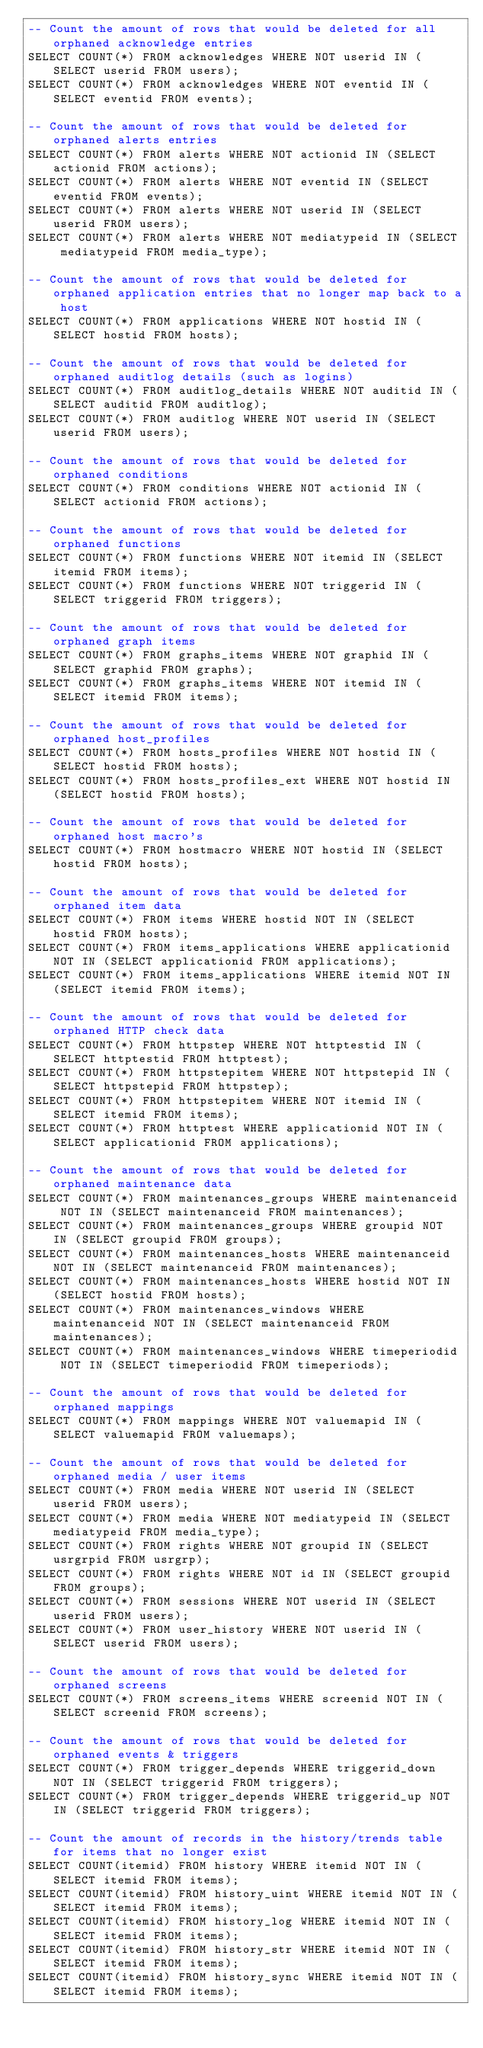<code> <loc_0><loc_0><loc_500><loc_500><_SQL_>-- Count the amount of rows that would be deleted for all orphaned acknowledge entries
SELECT COUNT(*) FROM acknowledges WHERE NOT userid IN (SELECT userid FROM users);
SELECT COUNT(*) FROM acknowledges WHERE NOT eventid IN (SELECT eventid FROM events);

-- Count the amount of rows that would be deleted for orphaned alerts entries
SELECT COUNT(*) FROM alerts WHERE NOT actionid IN (SELECT actionid FROM actions);
SELECT COUNT(*) FROM alerts WHERE NOT eventid IN (SELECT eventid FROM events);
SELECT COUNT(*) FROM alerts WHERE NOT userid IN (SELECT userid FROM users);
SELECT COUNT(*) FROM alerts WHERE NOT mediatypeid IN (SELECT mediatypeid FROM media_type);

-- Count the amount of rows that would be deleted for orphaned application entries that no longer map back to a host
SELECT COUNT(*) FROM applications WHERE NOT hostid IN (SELECT hostid FROM hosts);

-- Count the amount of rows that would be deleted for orphaned auditlog details (such as logins)
SELECT COUNT(*) FROM auditlog_details WHERE NOT auditid IN (SELECT auditid FROM auditlog);
SELECT COUNT(*) FROM auditlog WHERE NOT userid IN (SELECT userid FROM users);

-- Count the amount of rows that would be deleted for orphaned conditions
SELECT COUNT(*) FROM conditions WHERE NOT actionid IN (SELECT actionid FROM actions);

-- Count the amount of rows that would be deleted for orphaned functions
SELECT COUNT(*) FROM functions WHERE NOT itemid IN (SELECT itemid FROM items);
SELECT COUNT(*) FROM functions WHERE NOT triggerid IN (SELECT triggerid FROM triggers);

-- Count the amount of rows that would be deleted for orphaned graph items
SELECT COUNT(*) FROM graphs_items WHERE NOT graphid IN (SELECT graphid FROM graphs);
SELECT COUNT(*) FROM graphs_items WHERE NOT itemid IN (SELECT itemid FROM items);

-- Count the amount of rows that would be deleted for orphaned host_profiles
SELECT COUNT(*) FROM hosts_profiles WHERE NOT hostid IN (SELECT hostid FROM hosts);
SELECT COUNT(*) FROM hosts_profiles_ext WHERE NOT hostid IN (SELECT hostid FROM hosts);

-- Count the amount of rows that would be deleted for orphaned host macro's
SELECT COUNT(*) FROM hostmacro WHERE NOT hostid IN (SELECT hostid FROM hosts);

-- Count the amount of rows that would be deleted for orphaned item data
SELECT COUNT(*) FROM items WHERE hostid NOT IN (SELECT hostid FROM hosts);
SELECT COUNT(*) FROM items_applications WHERE applicationid NOT IN (SELECT applicationid FROM applications);
SELECT COUNT(*) FROM items_applications WHERE itemid NOT IN (SELECT itemid FROM items);

-- Count the amount of rows that would be deleted for orphaned HTTP check data
SELECT COUNT(*) FROM httpstep WHERE NOT httptestid IN (SELECT httptestid FROM httptest);
SELECT COUNT(*) FROM httpstepitem WHERE NOT httpstepid IN (SELECT httpstepid FROM httpstep);
SELECT COUNT(*) FROM httpstepitem WHERE NOT itemid IN (SELECT itemid FROM items);
SELECT COUNT(*) FROM httptest WHERE applicationid NOT IN (SELECT applicationid FROM applications);

-- Count the amount of rows that would be deleted for orphaned maintenance data
SELECT COUNT(*) FROM maintenances_groups WHERE maintenanceid NOT IN (SELECT maintenanceid FROM maintenances);
SELECT COUNT(*) FROM maintenances_groups WHERE groupid NOT IN (SELECT groupid FROM groups);
SELECT COUNT(*) FROM maintenances_hosts WHERE maintenanceid NOT IN (SELECT maintenanceid FROM maintenances);
SELECT COUNT(*) FROM maintenances_hosts WHERE hostid NOT IN (SELECT hostid FROM hosts);
SELECT COUNT(*) FROM maintenances_windows WHERE maintenanceid NOT IN (SELECT maintenanceid FROM maintenances);
SELECT COUNT(*) FROM maintenances_windows WHERE timeperiodid NOT IN (SELECT timeperiodid FROM timeperiods);

-- Count the amount of rows that would be deleted for orphaned mappings
SELECT COUNT(*) FROM mappings WHERE NOT valuemapid IN (SELECT valuemapid FROM valuemaps);

-- Count the amount of rows that would be deleted for orphaned media / user items
SELECT COUNT(*) FROM media WHERE NOT userid IN (SELECT userid FROM users);
SELECT COUNT(*) FROM media WHERE NOT mediatypeid IN (SELECT mediatypeid FROM media_type);
SELECT COUNT(*) FROM rights WHERE NOT groupid IN (SELECT usrgrpid FROM usrgrp);
SELECT COUNT(*) FROM rights WHERE NOT id IN (SELECT groupid FROM groups);
SELECT COUNT(*) FROM sessions WHERE NOT userid IN (SELECT userid FROM users);
SELECT COUNT(*) FROM user_history WHERE NOT userid IN (SELECT userid FROM users);

-- Count the amount of rows that would be deleted for orphaned screens
SELECT COUNT(*) FROM screens_items WHERE screenid NOT IN (SELECT screenid FROM screens);

-- Count the amount of rows that would be deleted for orphaned events & triggers
SELECT COUNT(*) FROM trigger_depends WHERE triggerid_down NOT IN (SELECT triggerid FROM triggers);
SELECT COUNT(*) FROM trigger_depends WHERE triggerid_up NOT IN (SELECT triggerid FROM triggers);

-- Count the amount of records in the history/trends table for items that no longer exist
SELECT COUNT(itemid) FROM history WHERE itemid NOT IN (SELECT itemid FROM items);
SELECT COUNT(itemid) FROM history_uint WHERE itemid NOT IN (SELECT itemid FROM items);
SELECT COUNT(itemid) FROM history_log WHERE itemid NOT IN (SELECT itemid FROM items);
SELECT COUNT(itemid) FROM history_str WHERE itemid NOT IN (SELECT itemid FROM items);
SELECT COUNT(itemid) FROM history_sync WHERE itemid NOT IN (SELECT itemid FROM items);</code> 